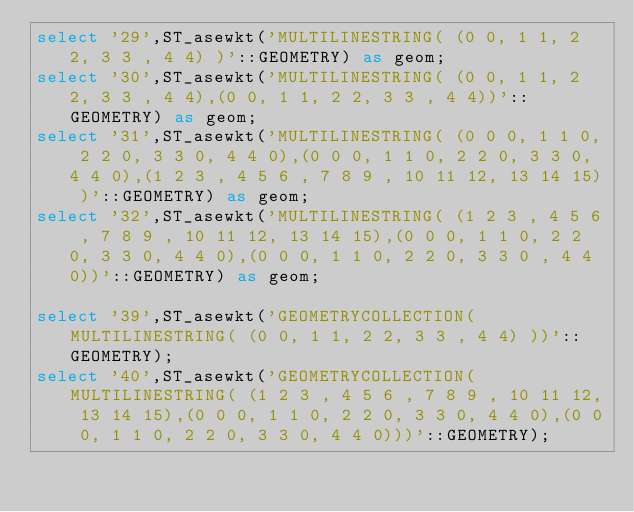Convert code to text. <code><loc_0><loc_0><loc_500><loc_500><_SQL_>select '29',ST_asewkt('MULTILINESTRING( (0 0, 1 1, 2 2, 3 3 , 4 4) )'::GEOMETRY) as geom;
select '30',ST_asewkt('MULTILINESTRING( (0 0, 1 1, 2 2, 3 3 , 4 4),(0 0, 1 1, 2 2, 3 3 , 4 4))'::GEOMETRY) as geom;
select '31',ST_asewkt('MULTILINESTRING( (0 0 0, 1 1 0, 2 2 0, 3 3 0, 4 4 0),(0 0 0, 1 1 0, 2 2 0, 3 3 0, 4 4 0),(1 2 3 , 4 5 6 , 7 8 9 , 10 11 12, 13 14 15) )'::GEOMETRY) as geom;
select '32',ST_asewkt('MULTILINESTRING( (1 2 3 , 4 5 6 , 7 8 9 , 10 11 12, 13 14 15),(0 0 0, 1 1 0, 2 2 0, 3 3 0, 4 4 0),(0 0 0, 1 1 0, 2 2 0, 3 3 0 , 4 4 0))'::GEOMETRY) as geom;

select '39',ST_asewkt('GEOMETRYCOLLECTION(MULTILINESTRING( (0 0, 1 1, 2 2, 3 3 , 4 4) ))'::GEOMETRY);
select '40',ST_asewkt('GEOMETRYCOLLECTION(MULTILINESTRING( (1 2 3 , 4 5 6 , 7 8 9 , 10 11 12, 13 14 15),(0 0 0, 1 1 0, 2 2 0, 3 3 0, 4 4 0),(0 0 0, 1 1 0, 2 2 0, 3 3 0, 4 4 0)))'::GEOMETRY);

</code> 